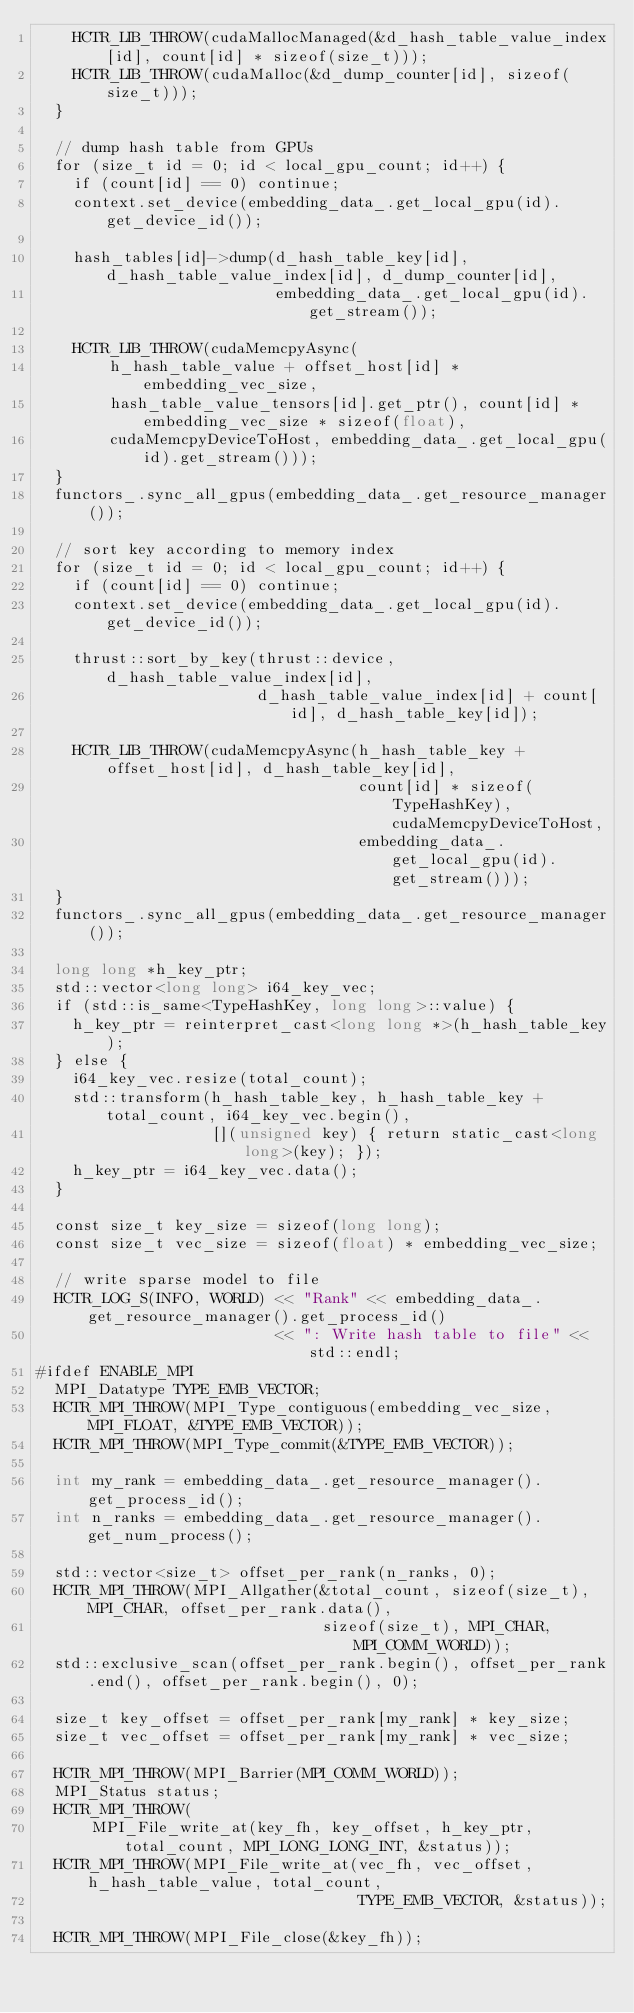Convert code to text. <code><loc_0><loc_0><loc_500><loc_500><_Cuda_>    HCTR_LIB_THROW(cudaMallocManaged(&d_hash_table_value_index[id], count[id] * sizeof(size_t)));
    HCTR_LIB_THROW(cudaMalloc(&d_dump_counter[id], sizeof(size_t)));
  }

  // dump hash table from GPUs
  for (size_t id = 0; id < local_gpu_count; id++) {
    if (count[id] == 0) continue;
    context.set_device(embedding_data_.get_local_gpu(id).get_device_id());

    hash_tables[id]->dump(d_hash_table_key[id], d_hash_table_value_index[id], d_dump_counter[id],
                          embedding_data_.get_local_gpu(id).get_stream());

    HCTR_LIB_THROW(cudaMemcpyAsync(
        h_hash_table_value + offset_host[id] * embedding_vec_size,
        hash_table_value_tensors[id].get_ptr(), count[id] * embedding_vec_size * sizeof(float),
        cudaMemcpyDeviceToHost, embedding_data_.get_local_gpu(id).get_stream()));
  }
  functors_.sync_all_gpus(embedding_data_.get_resource_manager());

  // sort key according to memory index
  for (size_t id = 0; id < local_gpu_count; id++) {
    if (count[id] == 0) continue;
    context.set_device(embedding_data_.get_local_gpu(id).get_device_id());

    thrust::sort_by_key(thrust::device, d_hash_table_value_index[id],
                        d_hash_table_value_index[id] + count[id], d_hash_table_key[id]);

    HCTR_LIB_THROW(cudaMemcpyAsync(h_hash_table_key + offset_host[id], d_hash_table_key[id],
                                   count[id] * sizeof(TypeHashKey), cudaMemcpyDeviceToHost,
                                   embedding_data_.get_local_gpu(id).get_stream()));
  }
  functors_.sync_all_gpus(embedding_data_.get_resource_manager());

  long long *h_key_ptr;
  std::vector<long long> i64_key_vec;
  if (std::is_same<TypeHashKey, long long>::value) {
    h_key_ptr = reinterpret_cast<long long *>(h_hash_table_key);
  } else {
    i64_key_vec.resize(total_count);
    std::transform(h_hash_table_key, h_hash_table_key + total_count, i64_key_vec.begin(),
                   [](unsigned key) { return static_cast<long long>(key); });
    h_key_ptr = i64_key_vec.data();
  }

  const size_t key_size = sizeof(long long);
  const size_t vec_size = sizeof(float) * embedding_vec_size;

  // write sparse model to file
  HCTR_LOG_S(INFO, WORLD) << "Rank" << embedding_data_.get_resource_manager().get_process_id()
                          << ": Write hash table to file" << std::endl;
#ifdef ENABLE_MPI
  MPI_Datatype TYPE_EMB_VECTOR;
  HCTR_MPI_THROW(MPI_Type_contiguous(embedding_vec_size, MPI_FLOAT, &TYPE_EMB_VECTOR));
  HCTR_MPI_THROW(MPI_Type_commit(&TYPE_EMB_VECTOR));

  int my_rank = embedding_data_.get_resource_manager().get_process_id();
  int n_ranks = embedding_data_.get_resource_manager().get_num_process();

  std::vector<size_t> offset_per_rank(n_ranks, 0);
  HCTR_MPI_THROW(MPI_Allgather(&total_count, sizeof(size_t), MPI_CHAR, offset_per_rank.data(),
                               sizeof(size_t), MPI_CHAR, MPI_COMM_WORLD));
  std::exclusive_scan(offset_per_rank.begin(), offset_per_rank.end(), offset_per_rank.begin(), 0);

  size_t key_offset = offset_per_rank[my_rank] * key_size;
  size_t vec_offset = offset_per_rank[my_rank] * vec_size;

  HCTR_MPI_THROW(MPI_Barrier(MPI_COMM_WORLD));
  MPI_Status status;
  HCTR_MPI_THROW(
      MPI_File_write_at(key_fh, key_offset, h_key_ptr, total_count, MPI_LONG_LONG_INT, &status));
  HCTR_MPI_THROW(MPI_File_write_at(vec_fh, vec_offset, h_hash_table_value, total_count,
                                   TYPE_EMB_VECTOR, &status));

  HCTR_MPI_THROW(MPI_File_close(&key_fh));</code> 